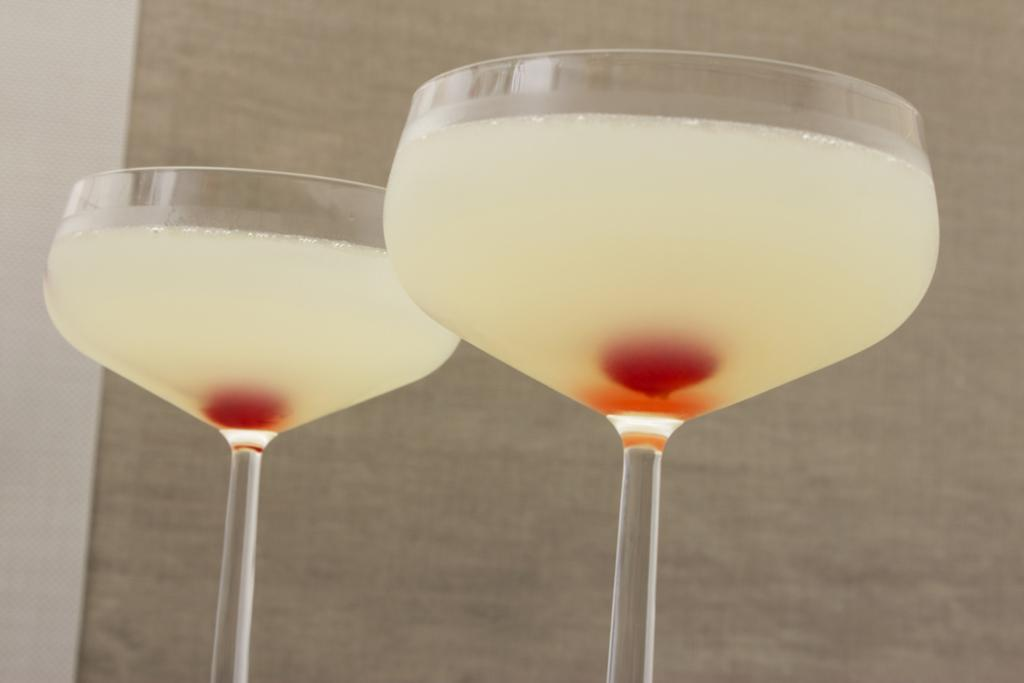How many glasses are visible in the image? There are two glasses in the image. What is inside the glasses? The glasses contain a white color liquid. What is the color of the object inside the glasses? There is a red color thing inside the glasses. What can be seen in the background of the image? There is a wall in the background of the image. What type of texture can be seen on the glasses in the image? The provided facts do not mention any specific texture on the glasses, so we cannot determine the texture from the image. 